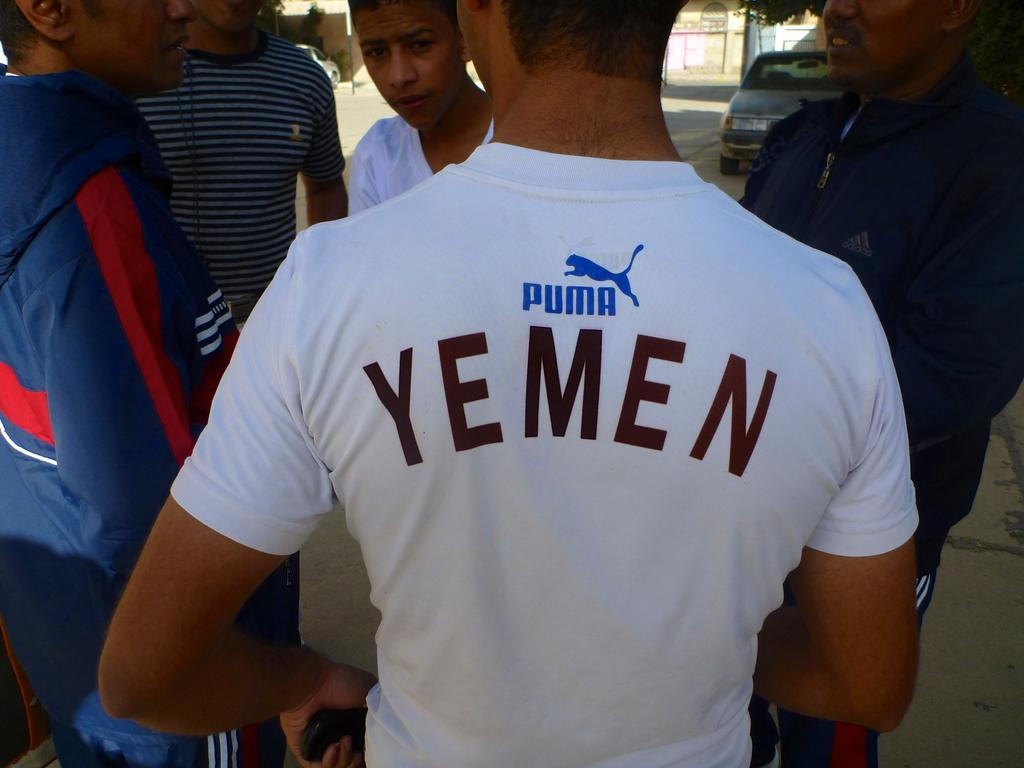<image>
Describe the image concisely. A man wearing a white Puma shirt that says "Yemen" is talking with other men. 